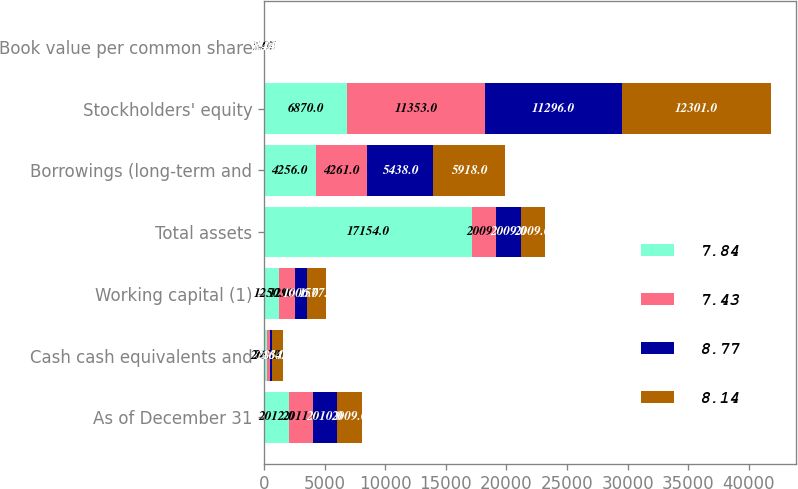Convert chart. <chart><loc_0><loc_0><loc_500><loc_500><stacked_bar_chart><ecel><fcel>As of December 31<fcel>Cash cash equivalents and<fcel>Working capital (1)<fcel>Total assets<fcel>Borrowings (long-term and<fcel>Stockholders' equity<fcel>Book value per common share<nl><fcel>7.84<fcel>2012<fcel>207<fcel>1250<fcel>17154<fcel>4256<fcel>6870<fcel>5.07<nl><fcel>7.43<fcel>2011<fcel>267<fcel>1298<fcel>2009<fcel>4261<fcel>11353<fcel>7.84<nl><fcel>8.77<fcel>2010<fcel>213<fcel>1006<fcel>2009<fcel>5438<fcel>11296<fcel>7.43<nl><fcel>8.14<fcel>2009<fcel>864<fcel>1577<fcel>2009<fcel>5918<fcel>12301<fcel>8.14<nl></chart> 